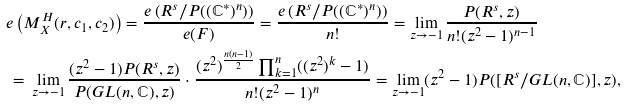<formula> <loc_0><loc_0><loc_500><loc_500>& e \left ( M _ { X } ^ { H } ( r , c _ { 1 } , c _ { 2 } ) \right ) = \frac { e \left ( R ^ { s } / P ( ( \mathbb { C } ^ { * } ) ^ { n } ) \right ) } { e ( F ) } = \frac { e \left ( R ^ { s } / P ( ( \mathbb { C } ^ { * } ) ^ { n } ) \right ) } { n ! } = \lim _ { z \rightarrow - 1 } \frac { P ( R ^ { s } , z ) } { n ! ( z ^ { 2 } - 1 ) ^ { n - 1 } } \\ & \, = \, \lim _ { z \rightarrow - 1 } \frac { ( z ^ { 2 } - 1 ) P ( R ^ { s } , z ) } { P ( G L ( n , \mathbb { C } ) , z ) } \cdot \frac { ( z ^ { 2 } ) ^ { \frac { n ( n - 1 ) } { 2 } } \prod _ { k = 1 } ^ { n } ( ( z ^ { 2 } ) ^ { k } - 1 ) } { n ! ( z ^ { 2 } - 1 ) ^ { n } } = \lim _ { z \rightarrow - 1 } ( z ^ { 2 } - 1 ) P ( [ R ^ { s } / G L ( n , \mathbb { C } ) ] , z ) ,</formula> 